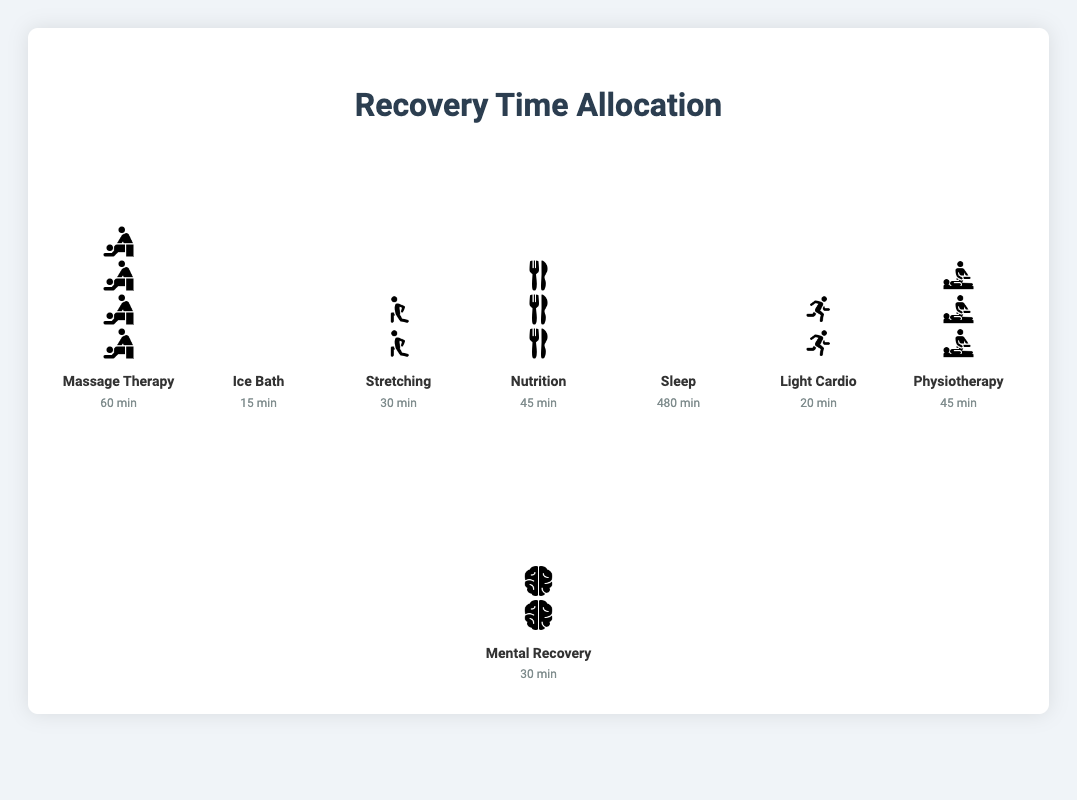What is the total recovery time allocated to Massage Therapy? Sum up the time spent on Massage Therapy, which is specified in the plot as 60 minutes.
Answer: 60 minutes What activity has the longest allocated recovery time? Identify the activity with the tallest stack of icons and the highest total minutes, which is Sleep with 480 minutes.
Answer: Sleep Which two activities have the same allocated recovery time? Look for activities with the same number of total icons. Nutrition and Physiotherapy both have 45 minutes.
Answer: Nutrition and Physiotherapy How much more time is allocated to Sleep compared to Mental Recovery? Subtract the minutes allocated to Mental Recovery from the minutes allocated to Sleep: 480 - 30 = 450 minutes.
Answer: 450 minutes What are the shortest and longest recovery activities? Identify the activities with the shortest and tallest icon stacks. Ice Bath is the shortest with 15 minutes; Sleep is the longest with 480 minutes.
Answer: Ice Bath and Sleep How much total time is allocated for stretching and light cardio combined? Add the minutes for Stretching and Light Cardio: 30 + 20 = 50 minutes.
Answer: 50 minutes Which activities have more than 30 but less than 60 minutes allocated? Identify activities with total minutes between 30 and 60: Massage Therapy (60), Nutrition (45), and Physiotherapy (45). Only Nutrition and Physiotherapy fit the range.
Answer: Nutrition and Physiotherapy How many icons represent the activity with the least allocated time? Find the activity with the least minutes (Ice Bath, 15 minutes) and calculate the number of icons (Each icon represents 15 minutes, so 15 / 15 = 1 icon).
Answer: 1 icon 